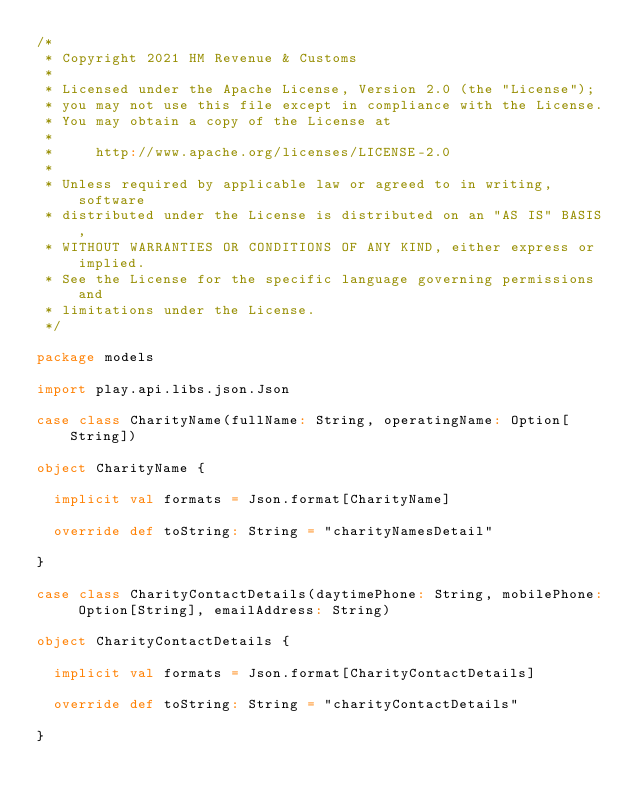<code> <loc_0><loc_0><loc_500><loc_500><_Scala_>/*
 * Copyright 2021 HM Revenue & Customs
 *
 * Licensed under the Apache License, Version 2.0 (the "License");
 * you may not use this file except in compliance with the License.
 * You may obtain a copy of the License at
 *
 *     http://www.apache.org/licenses/LICENSE-2.0
 *
 * Unless required by applicable law or agreed to in writing, software
 * distributed under the License is distributed on an "AS IS" BASIS,
 * WITHOUT WARRANTIES OR CONDITIONS OF ANY KIND, either express or implied.
 * See the License for the specific language governing permissions and
 * limitations under the License.
 */

package models

import play.api.libs.json.Json

case class CharityName(fullName: String, operatingName: Option[String])

object CharityName {

  implicit val formats = Json.format[CharityName]

  override def toString: String = "charityNamesDetail"

}

case class CharityContactDetails(daytimePhone: String, mobilePhone: Option[String], emailAddress: String)

object CharityContactDetails {

  implicit val formats = Json.format[CharityContactDetails]

  override def toString: String = "charityContactDetails"

}
</code> 